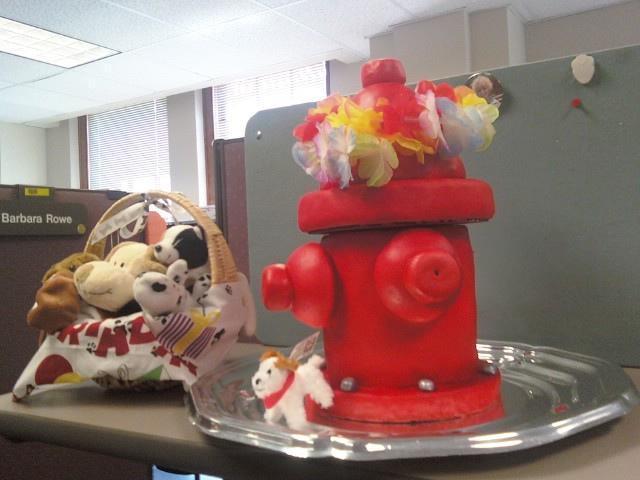How many dogs are in the picture?
Give a very brief answer. 2. How many umbrellas are in the picture?
Give a very brief answer. 0. 